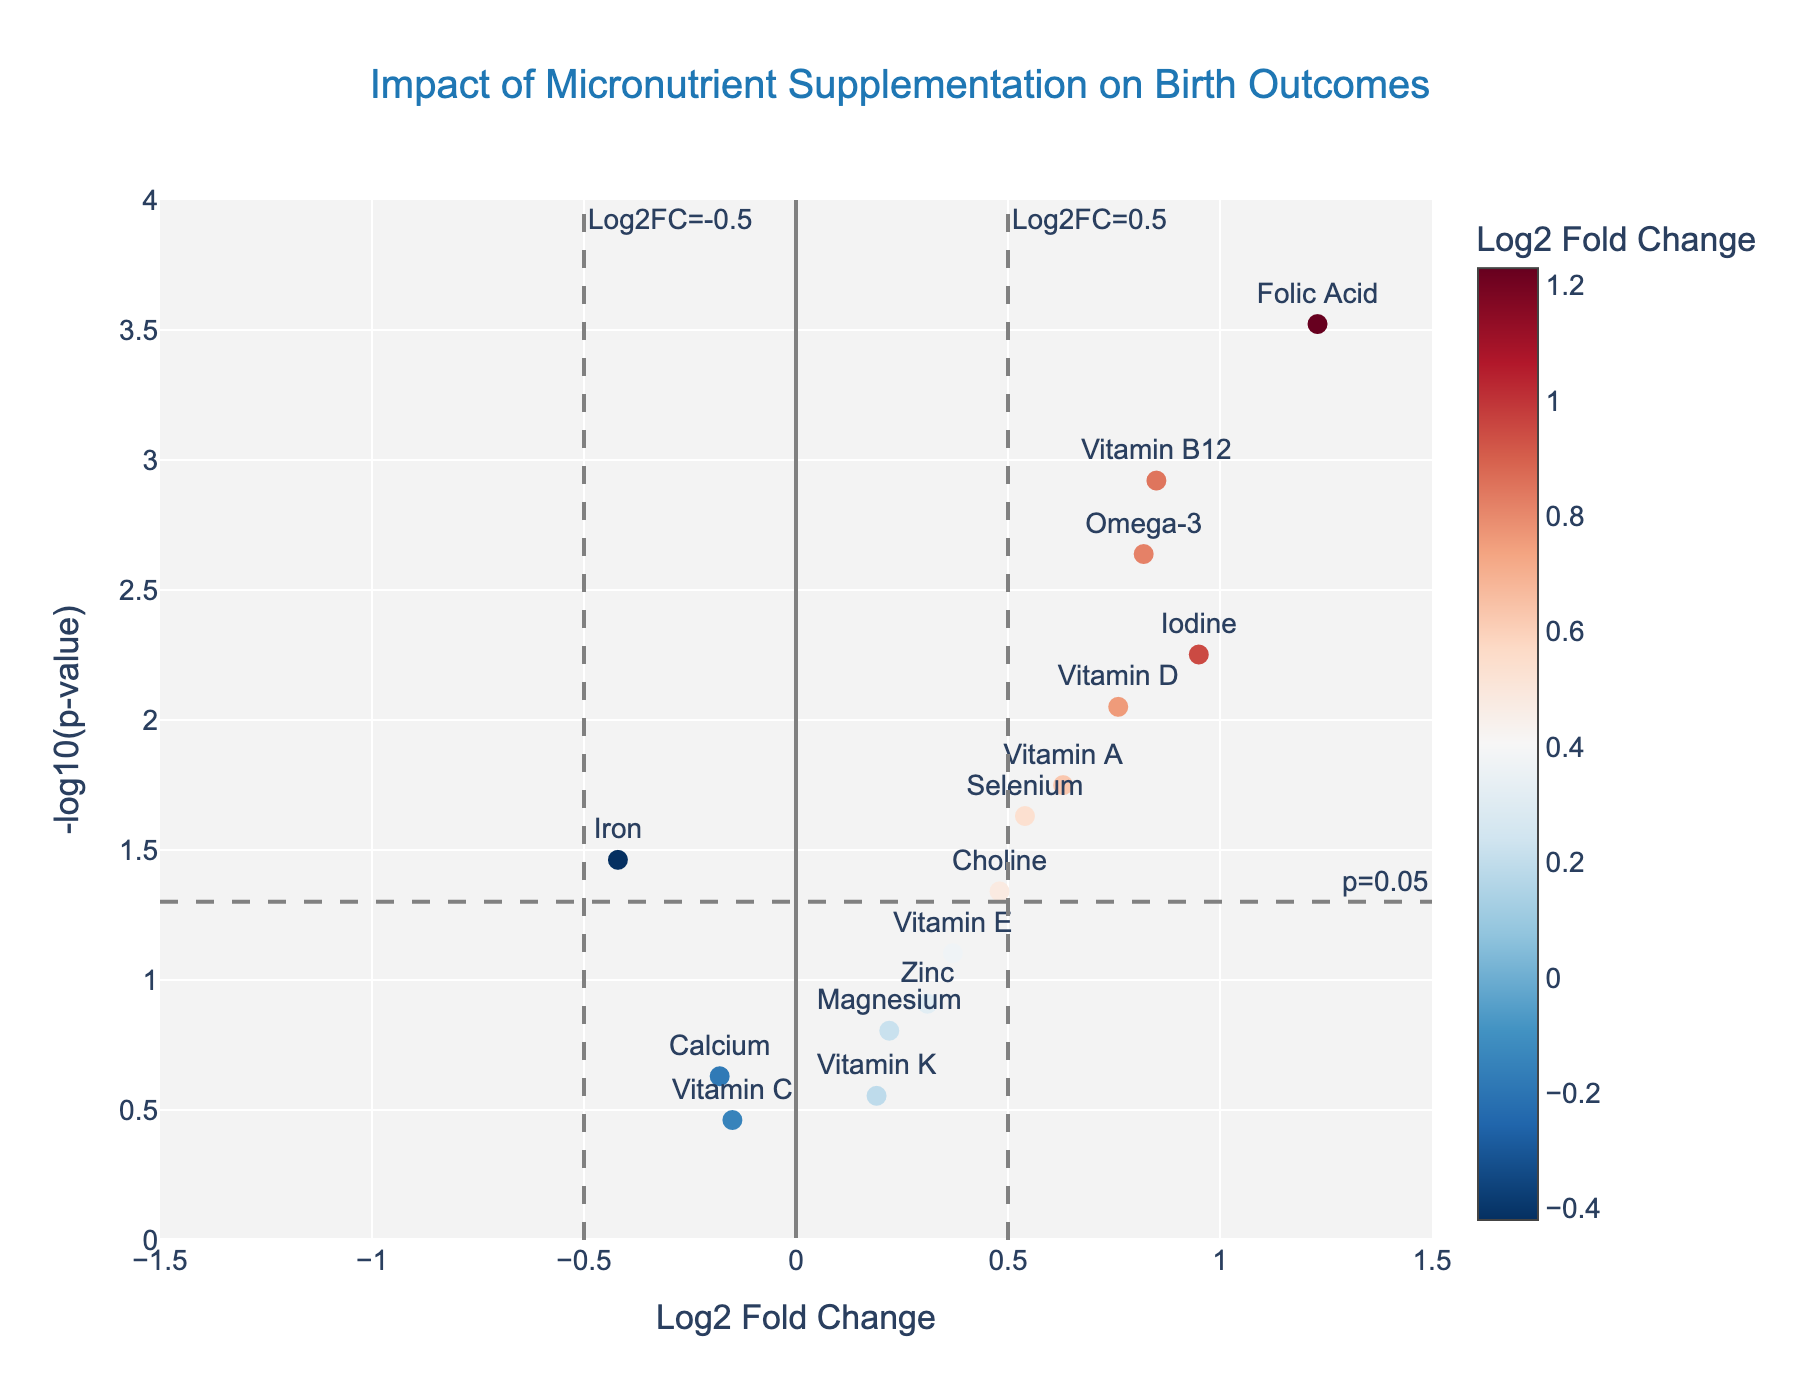What is the title of the plot? The title is usually placed at the top center of the plot. In this case, it is "Impact of Micronutrient Supplementation on Birth Outcomes".
Answer: Impact of Micronutrient Supplementation on Birth Outcomes How many micronutrients have a p-value less than 0.05? Micronutrients with a p-value less than 0.05 will have their corresponding -log10(p-value) greater than 1.3. Count the data points where this condition holds.
Answer: 8 Which micronutrient has the highest log2 fold change (Log2FC) value? The log2 fold change is represented on the x-axis. The highest value corresponds to the farthest right data point. In this case, "Folic Acid" has the highest value.
Answer: Folic Acid Which micronutrient has the lowest p-value? The p-value is represented on the y-axis as -log10(p-value). The highest y-value corresponds to the smallest p-value. In this case, "Folic Acid" has the smallest p-value.
Answer: Folic Acid What is the log2 fold change and p-value of Vitamin D? Locate "Vitamin D" on the plot and trace its position along the x-axis (Log2FC) and y-axis (-log10(p-value)).
Answer: Log2FC: 0.76, P-value: 0.0089 Which micronutrient has a positive log2 fold change but is not statistically significant (p>0.05)? Micronutrients with positive log2 fold change lie on the right side of the y-axis and statistically insignificant values have -log10(p-value) less than 1.3. "Zinc", "Calcium", "Magnesium", "Vitamin E", and "Vitamin K" fit this description. Among them, "Zinc" has a positive log2 fold change and is not significant.
Answer: Zinc Between Vitamin B12 and Iron, which has a greater log2 fold change and which has a smaller p-value? Vitamin B12 has a higher log2 fold change (0.85 vs -0.42). For p-value, since -log10(0.0012) > -log10(0.0345), Vitamin B12 has a smaller p-value.
Answer: Vitamin B12 has greater Log2FC and smaller p-value How many micronutrients have a negative log2 fold change? Micronutrients with negative log2 fold change are found to the left of the y-axis. Count these data points. They are "Iron", "Calcium", and "Vitamin C".
Answer: 3 What are the log2 fold change and p-value for Omega-3? Locate "Omega-3" on the plot and determine the values on the x-axis and y-axis according to its position.
Answer: Log2FC: 0.82, P-value: 0.0023 Which micronutrients have a p-value greater than 0.05 and a log2 fold change smaller than 0.2? These micronutrients will have -log10(p-value) less than 1.3 and be located left of the vertical line at 0.2 on the x-axis. "Vitamin C" fits these conditions.
Answer: Vitamin C 